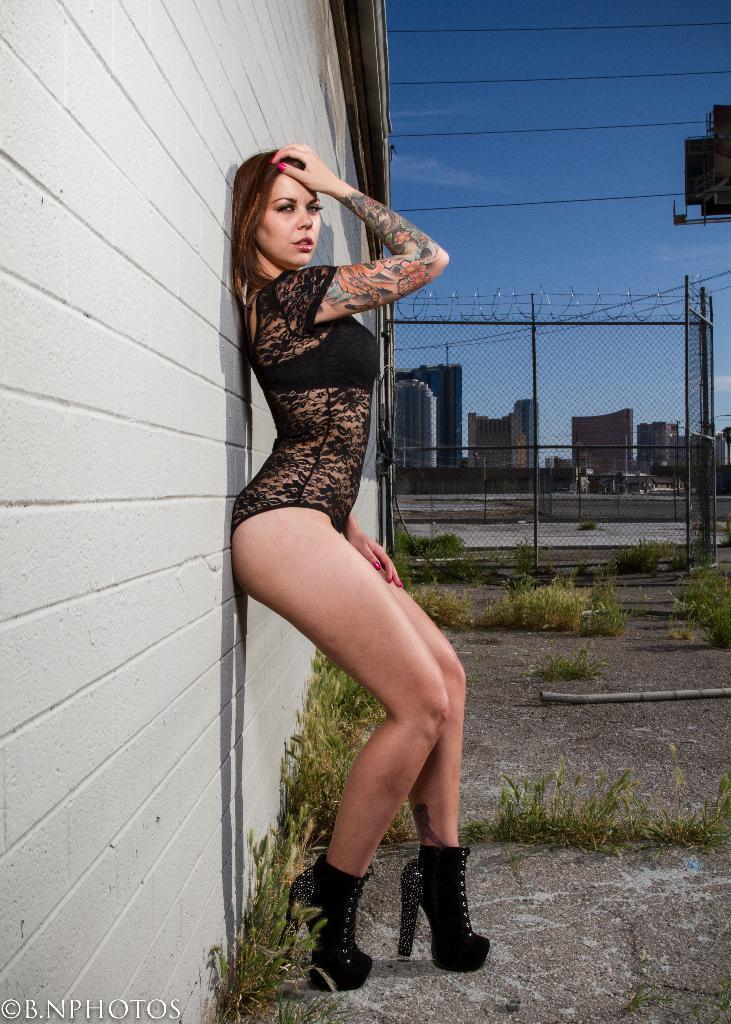Please provide a concise description of this image. In this image there is a woman standing. Behind her there is a wall. There is a fencing near to the wall. In the background there are buildings. At the top there is the sky. There are plants and grass on the ground. In the bottom left there is text on the image. 